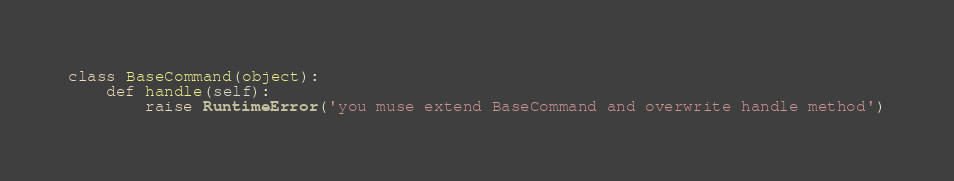<code> <loc_0><loc_0><loc_500><loc_500><_Python_>class BaseCommand(object):
    def handle(self):
        raise RuntimeError('you muse extend BaseCommand and overwrite handle method')</code> 